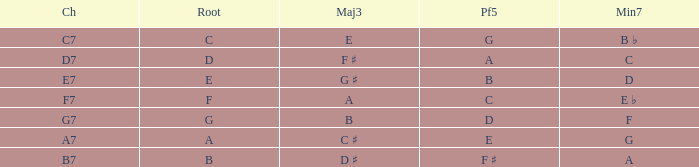What is the Major third with a Perfect fifth that is d? B. 